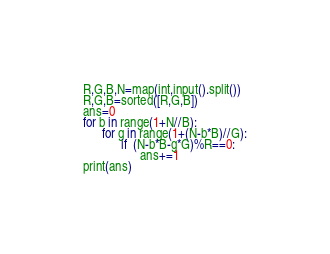<code> <loc_0><loc_0><loc_500><loc_500><_Python_>R,G,B,N=map(int,input().split())
R,G,B=sorted([R,G,B])
ans=0
for b in range(1+N//B):
      for g in range(1+(N-b*B)//G):
            if  (N-b*B-g*G)%R==0:
                  ans+=1
print(ans)</code> 